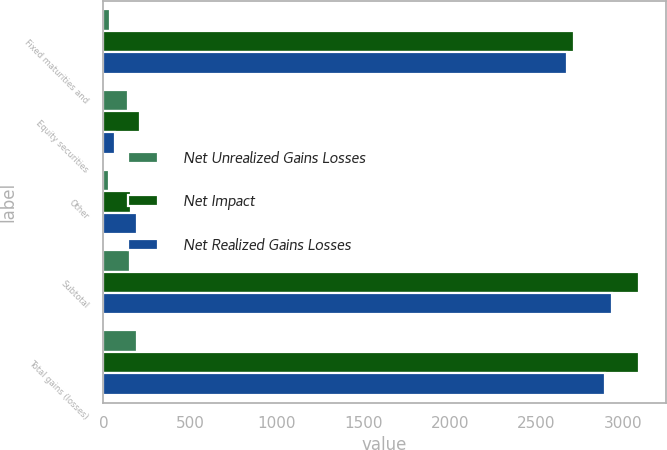<chart> <loc_0><loc_0><loc_500><loc_500><stacked_bar_chart><ecel><fcel>Fixed maturities and<fcel>Equity securities<fcel>Other<fcel>Subtotal<fcel>Total gains (losses)<nl><fcel>Net Unrealized Gains Losses<fcel>41<fcel>145<fcel>31<fcel>155<fcel>196<nl><fcel>Net Impact<fcel>2717<fcel>213<fcel>162<fcel>3092<fcel>3092<nl><fcel>Net Realized Gains Losses<fcel>2676<fcel>68<fcel>193<fcel>2937<fcel>2896<nl></chart> 